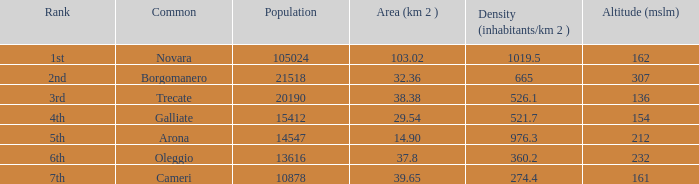Which common has a size (km2) of 3 Trecate. 